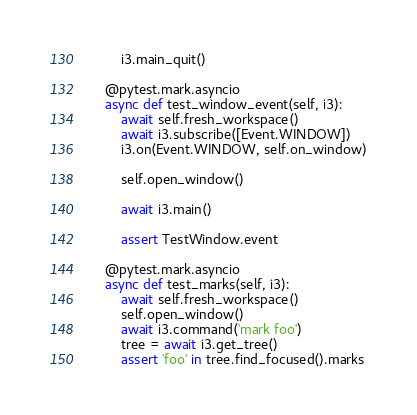Convert code to text. <code><loc_0><loc_0><loc_500><loc_500><_Python_>        i3.main_quit()

    @pytest.mark.asyncio
    async def test_window_event(self, i3):
        await self.fresh_workspace()
        await i3.subscribe([Event.WINDOW])
        i3.on(Event.WINDOW, self.on_window)

        self.open_window()

        await i3.main()

        assert TestWindow.event

    @pytest.mark.asyncio
    async def test_marks(self, i3):
        await self.fresh_workspace()
        self.open_window()
        await i3.command('mark foo')
        tree = await i3.get_tree()
        assert 'foo' in tree.find_focused().marks
</code> 